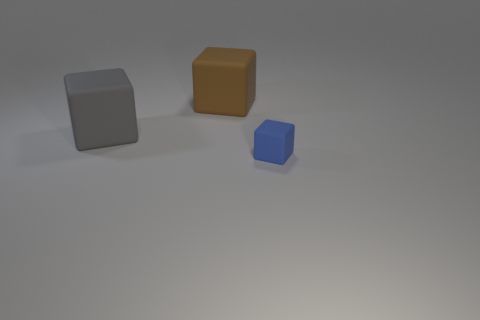Subtract all large cubes. How many cubes are left? 1 Add 1 brown matte objects. How many objects exist? 4 Subtract all cyan blocks. Subtract all green balls. How many blocks are left? 3 Subtract all tiny blue matte things. Subtract all tiny objects. How many objects are left? 1 Add 1 big brown rubber objects. How many big brown rubber objects are left? 2 Add 1 small purple rubber cylinders. How many small purple rubber cylinders exist? 1 Subtract 0 blue cylinders. How many objects are left? 3 